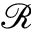<formula> <loc_0><loc_0><loc_500><loc_500>\mathcal { R }</formula> 